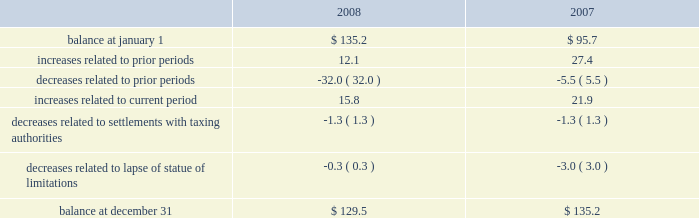Reinvested for continued use in foreign operations .
If the total undistributed earnings of foreign subsidiaries were remitted , a significant amount of the additional tax would be offset by the allowable foreign tax credits .
It is not practical for us to determine the additional tax of remitting these earnings .
In september 2007 , we reached a settlement with the united states department of justice to resolve an investigation into financial relationships between major orthopaedic manufacturers and consulting orthopaedic surgeons .
Under the terms of the settlement , we paid a civil settlement amount of $ 169.5 million and we recorded an expense in that amount .
At the time , no tax benefit was recorded related to the settlement expense due to the uncertainty as to the tax treatment .
During the third quarter of 2008 , we reached an agreement with the u.s .
Internal revenue service ( irs ) confirming the deductibility of a portion of the settlement payment .
As a result , during 2008 we recorded a current tax benefit of $ 31.7 million .
In june 2006 , the financial accounting standards board ( fasb ) issued interpretation no .
48 , accounting for uncertainty in income taxes 2013 an interpretation of fasb statement no .
109 , accounting for income taxes ( fin 48 ) .
Fin 48 addresses the determination of whether tax benefits claimed or expected to be claimed on a tax return should be recorded in the financial statements .
Under fin 48 , we may recognize the tax benefit from an uncertain tax position only if it is more likely than not that the tax position will be sustained on examination by the taxing authorities , based on the technical merits of the position .
The tax benefits recognized in the financial statements from such a position should be measured based on the largest benefit that has a greater than fifty percent likelihood of being realized upon ultimate settlement .
Fin 48 also provides guidance on derecognition , classification , interest and penalties on income taxes , accounting in interim periods and requires increased disclosures .
We adopted fin 48 on january 1 , 2007 .
Prior to the adoption of fin 48 we had a long term tax liability for expected settlement of various federal , state and foreign income tax liabilities that was reflected net of the corollary tax impact of these expected settlements of $ 102.1 million , as well as a separate accrued interest liability of $ 1.7 million .
As a result of the adoption of fin 48 , we are required to present the different components of such liability on a gross basis versus the historical net presentation .
The adoption resulted in the financial statement liability for unrecognized tax benefits decreasing by $ 6.4 million as of january 1 , 2007 .
The adoption resulted in this decrease in the liability as well as a reduction to retained earnings of $ 4.8 million , a reduction in goodwill of $ 61.4 million , the establishment of a tax receivable of $ 58.2 million , which was recorded in other current and non-current assets on our consolidated balance sheet , and an increase in an interest/penalty payable of $ 7.9 million , all as of january 1 , 2007 .
Therefore , after the adoption of fin 48 , the amount of unrecognized tax benefits is $ 95.7 million as of january 1 , 2007 .
As of december 31 , 2008 , the amount of unrecognized tax benefits is $ 129.5 million .
Of this amount , $ 45.5 million would impact our effective tax rate if recognized .
$ 38.2 million of the $ 129.5 million liability for unrecognized tax benefits relate to tax positions of acquired entities taken prior to their acquisition by us .
Under fas 141 ( r ) , if these liabilities are settled for different amounts , they will affect the income tax expense in the period of reversal or settlement .
The following is a tabular reconciliation of the total amounts of unrecognized tax benefits ( in millions ) : .
We recognize accrued interest and penalties related to unrecognized tax benefits in income tax expense in the consolidated statements of earnings , which is consistent with the recognition of these items in prior reporting periods .
As of december 31 , 2007 , we recorded a liability of $ 19.6 million for accrued interest and penalties , of which $ 14.7 million would impact our effective tax rate , if recognized .
The amount of this liability is $ 22.9 million as of december 31 , 2008 .
Of this amount , $ 17.1 million would impact our effective tax rate , if recognized .
We expect that the amount of tax liability for unrecognized tax benefits will change in the next twelve months ; however , we do not expect these changes will have a significant impact on our results of operations or financial position .
The u.s .
Federal statute of limitations remains open for the year 2003 and onward .
The u.s .
Federal returns for years 2003 and 2004 are currently under examination by the irs .
On july 15 , 2008 , the irs issued its examination report .
We filed a formal protest on august 15 , 2008 and requested a conference with the appeals office regarding disputed issues .
Although the appeals process could take several years , we do not anticipate resolution of the audit will result in any significant impact on our results of operations , financial position or cash flows .
In addition , for the 1999 tax year of centerpulse , which we acquired in october 2003 , one issue remains in dispute .
State income tax returns are generally subject to examination for a period of 3 to 5 years after filing of the respective return .
The state impact of any federal changes remains subject to examination by various states for a period of up to one year after formal notification to the states .
We have various state income tax returns in the process of examination , administrative appeals or litigation .
It is z i m m e r h o l d i n g s , i n c .
2 0 0 8 f o r m 1 0 - k a n n u a l r e p o r t notes to consolidated financial statements ( continued ) %%transmsg*** transmitting job : c48761 pcn : 057000000 ***%%pcmsg|57 |00010|yes|no|02/24/2009 06:10|0|0|page is valid , no graphics -- color : d| .
What is the percentage change in unrecognized tax benefits between 2007 and 2008? 
Computations: ((129.5 - 135.2) / 135.2)
Answer: -0.04216. 